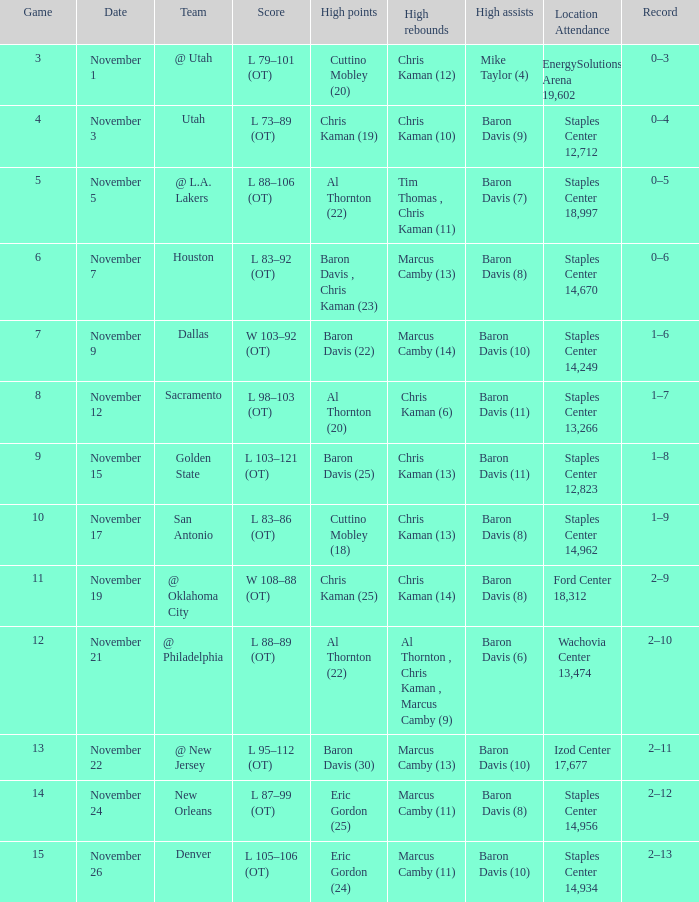List the peak moments for november 2 Eric Gordon (25). 